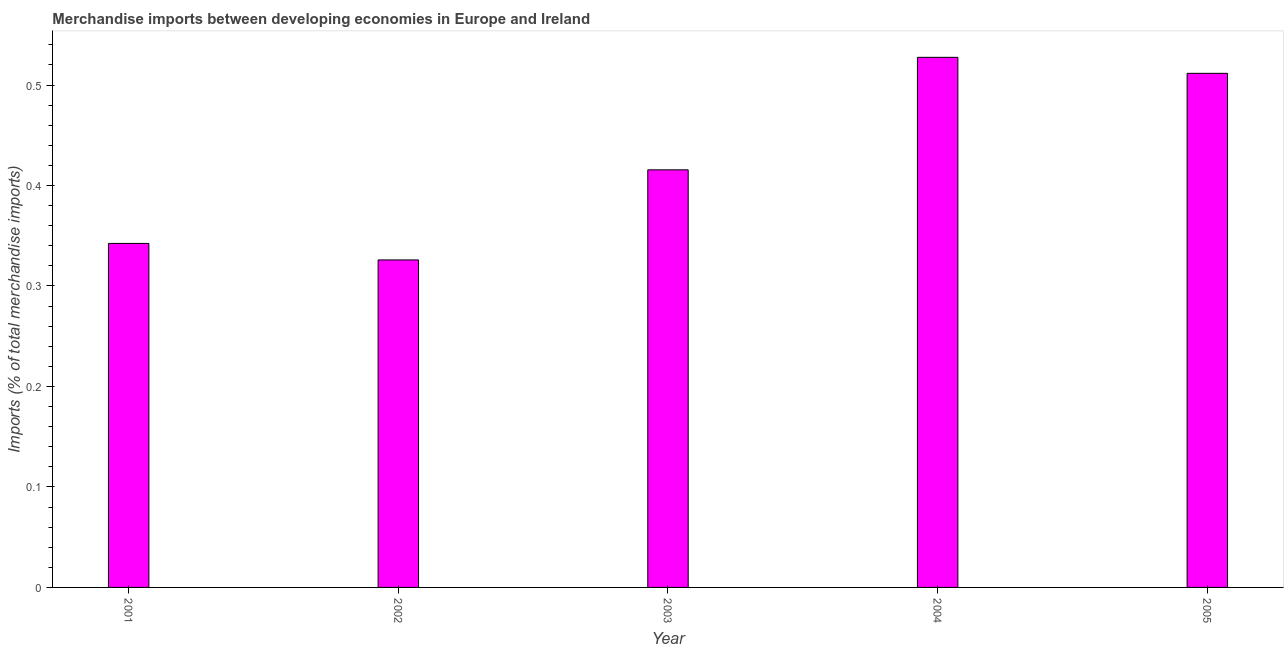Does the graph contain any zero values?
Offer a terse response. No. What is the title of the graph?
Your answer should be compact. Merchandise imports between developing economies in Europe and Ireland. What is the label or title of the X-axis?
Offer a very short reply. Year. What is the label or title of the Y-axis?
Your answer should be very brief. Imports (% of total merchandise imports). What is the merchandise imports in 2002?
Provide a succinct answer. 0.33. Across all years, what is the maximum merchandise imports?
Give a very brief answer. 0.53. Across all years, what is the minimum merchandise imports?
Your answer should be compact. 0.33. What is the sum of the merchandise imports?
Provide a short and direct response. 2.12. What is the difference between the merchandise imports in 2003 and 2005?
Keep it short and to the point. -0.1. What is the average merchandise imports per year?
Make the answer very short. 0.42. What is the median merchandise imports?
Provide a short and direct response. 0.42. In how many years, is the merchandise imports greater than 0.42 %?
Offer a terse response. 2. What is the ratio of the merchandise imports in 2002 to that in 2004?
Keep it short and to the point. 0.62. Is the merchandise imports in 2002 less than that in 2005?
Keep it short and to the point. Yes. Is the difference between the merchandise imports in 2001 and 2004 greater than the difference between any two years?
Your answer should be very brief. No. What is the difference between the highest and the second highest merchandise imports?
Give a very brief answer. 0.02. How many bars are there?
Your answer should be very brief. 5. Are all the bars in the graph horizontal?
Provide a short and direct response. No. How many years are there in the graph?
Offer a very short reply. 5. What is the difference between two consecutive major ticks on the Y-axis?
Your answer should be very brief. 0.1. What is the Imports (% of total merchandise imports) of 2001?
Give a very brief answer. 0.34. What is the Imports (% of total merchandise imports) of 2002?
Offer a terse response. 0.33. What is the Imports (% of total merchandise imports) in 2003?
Offer a very short reply. 0.42. What is the Imports (% of total merchandise imports) in 2004?
Your response must be concise. 0.53. What is the Imports (% of total merchandise imports) of 2005?
Provide a short and direct response. 0.51. What is the difference between the Imports (% of total merchandise imports) in 2001 and 2002?
Provide a succinct answer. 0.02. What is the difference between the Imports (% of total merchandise imports) in 2001 and 2003?
Give a very brief answer. -0.07. What is the difference between the Imports (% of total merchandise imports) in 2001 and 2004?
Your answer should be very brief. -0.19. What is the difference between the Imports (% of total merchandise imports) in 2001 and 2005?
Offer a very short reply. -0.17. What is the difference between the Imports (% of total merchandise imports) in 2002 and 2003?
Ensure brevity in your answer.  -0.09. What is the difference between the Imports (% of total merchandise imports) in 2002 and 2004?
Make the answer very short. -0.2. What is the difference between the Imports (% of total merchandise imports) in 2002 and 2005?
Your response must be concise. -0.19. What is the difference between the Imports (% of total merchandise imports) in 2003 and 2004?
Provide a succinct answer. -0.11. What is the difference between the Imports (% of total merchandise imports) in 2003 and 2005?
Keep it short and to the point. -0.1. What is the difference between the Imports (% of total merchandise imports) in 2004 and 2005?
Your answer should be very brief. 0.02. What is the ratio of the Imports (% of total merchandise imports) in 2001 to that in 2002?
Offer a terse response. 1.05. What is the ratio of the Imports (% of total merchandise imports) in 2001 to that in 2003?
Offer a very short reply. 0.82. What is the ratio of the Imports (% of total merchandise imports) in 2001 to that in 2004?
Your answer should be very brief. 0.65. What is the ratio of the Imports (% of total merchandise imports) in 2001 to that in 2005?
Your answer should be compact. 0.67. What is the ratio of the Imports (% of total merchandise imports) in 2002 to that in 2003?
Your answer should be compact. 0.78. What is the ratio of the Imports (% of total merchandise imports) in 2002 to that in 2004?
Offer a terse response. 0.62. What is the ratio of the Imports (% of total merchandise imports) in 2002 to that in 2005?
Your answer should be compact. 0.64. What is the ratio of the Imports (% of total merchandise imports) in 2003 to that in 2004?
Provide a short and direct response. 0.79. What is the ratio of the Imports (% of total merchandise imports) in 2003 to that in 2005?
Your answer should be compact. 0.81. What is the ratio of the Imports (% of total merchandise imports) in 2004 to that in 2005?
Keep it short and to the point. 1.03. 